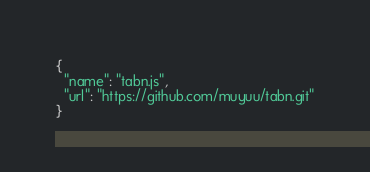Convert code to text. <code><loc_0><loc_0><loc_500><loc_500><_JavaScript_>{
  "name": "tabn.js",
  "url": "https://github.com/muyuu/tabn.git"
}
</code> 